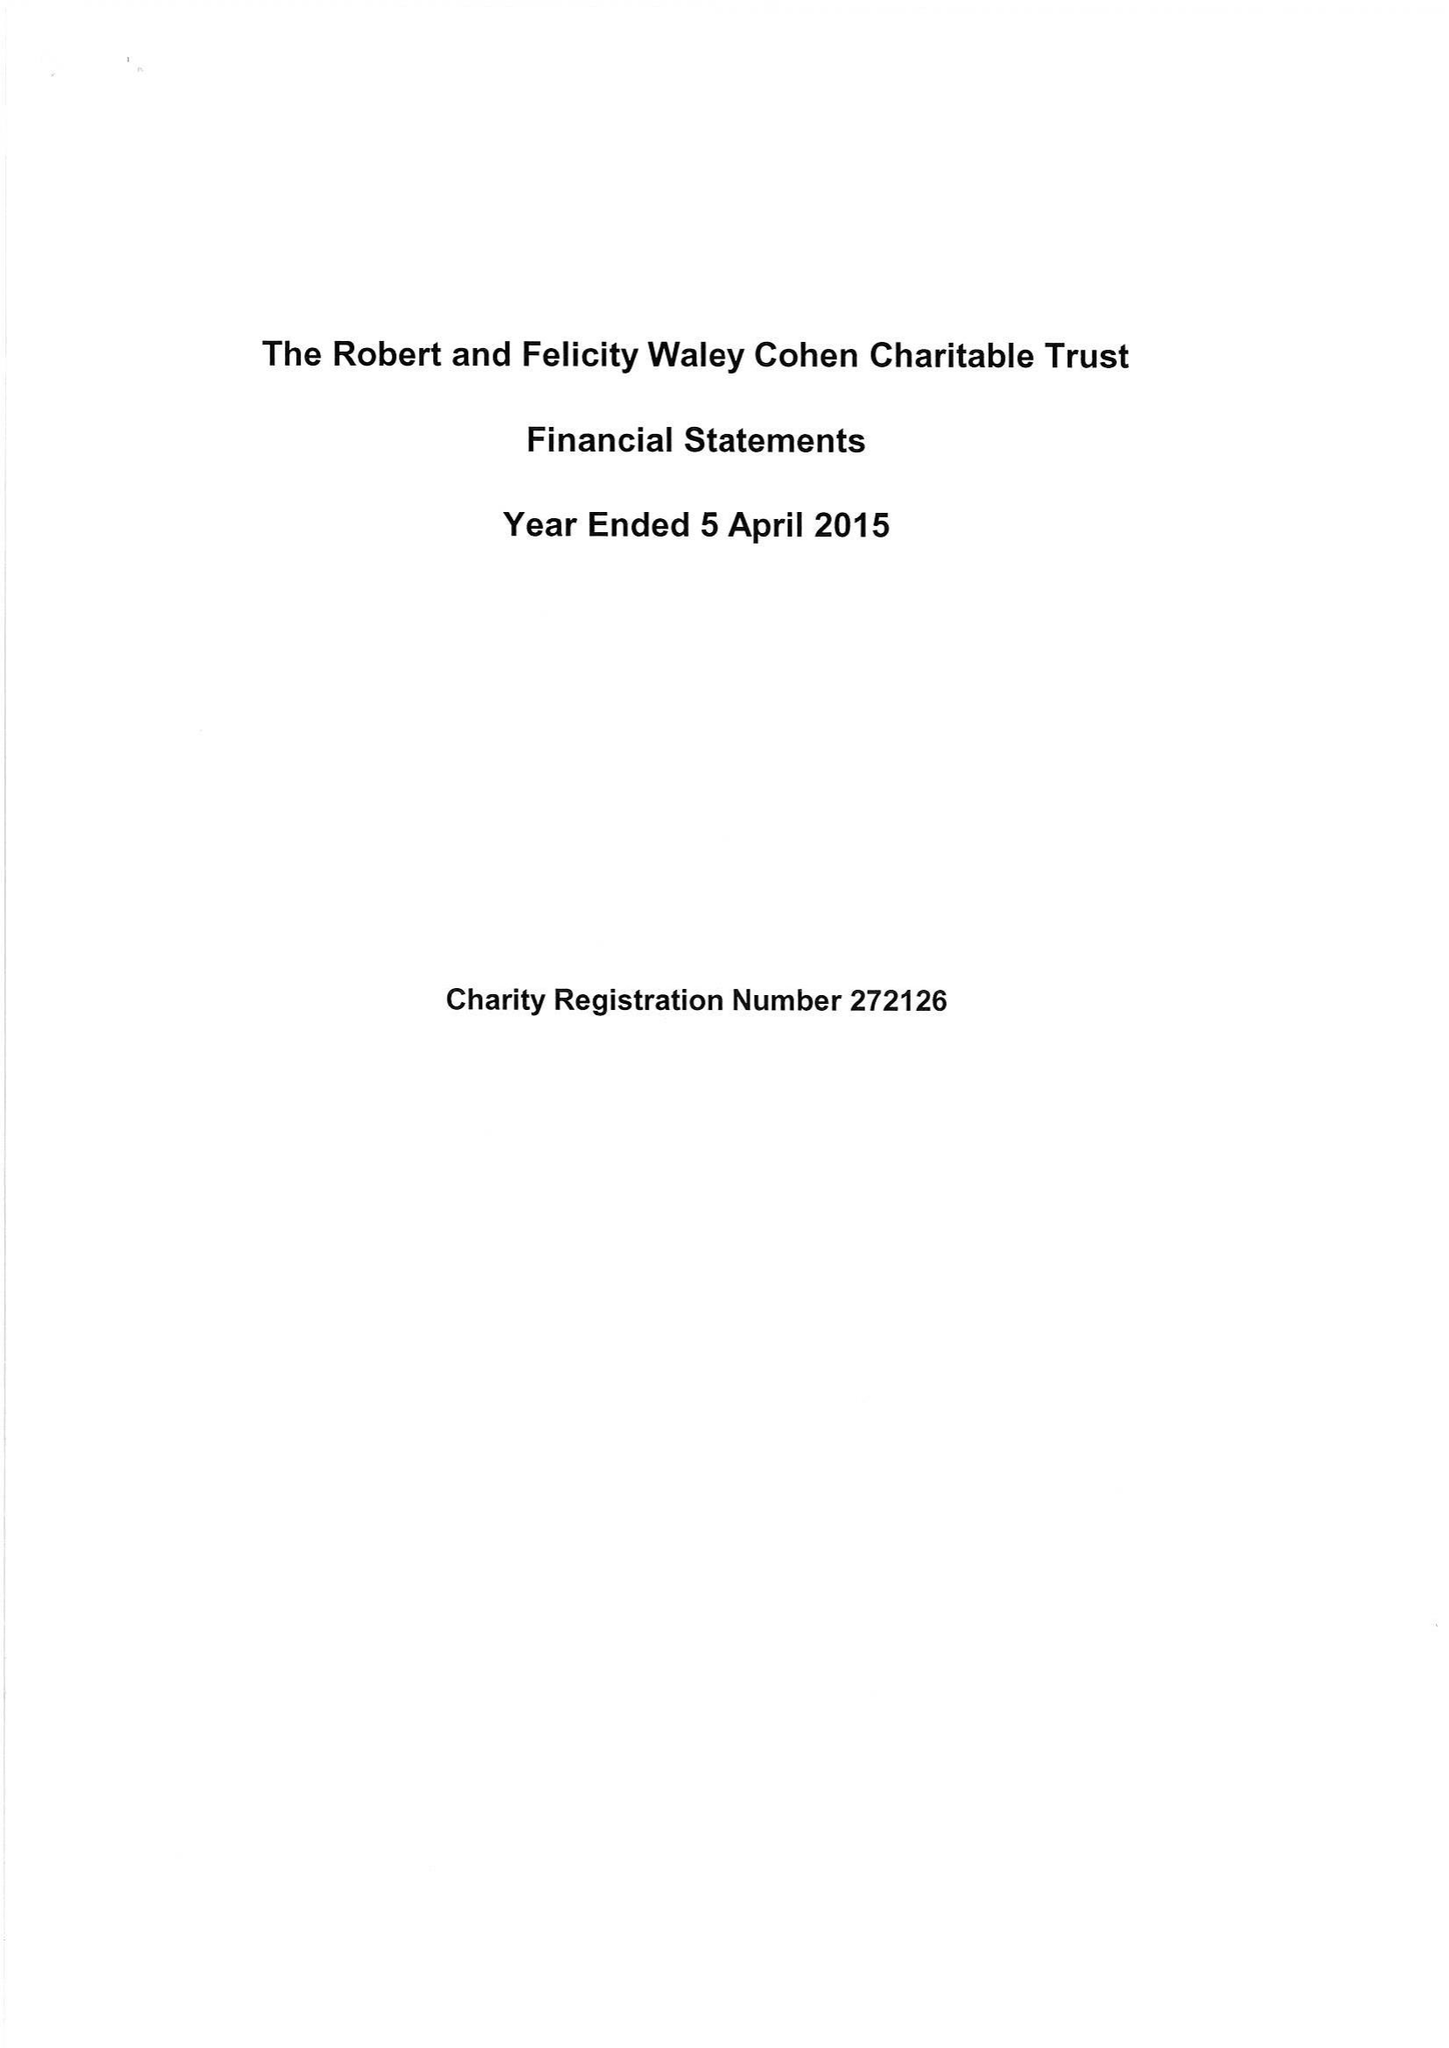What is the value for the report_date?
Answer the question using a single word or phrase. 2015-04-05 